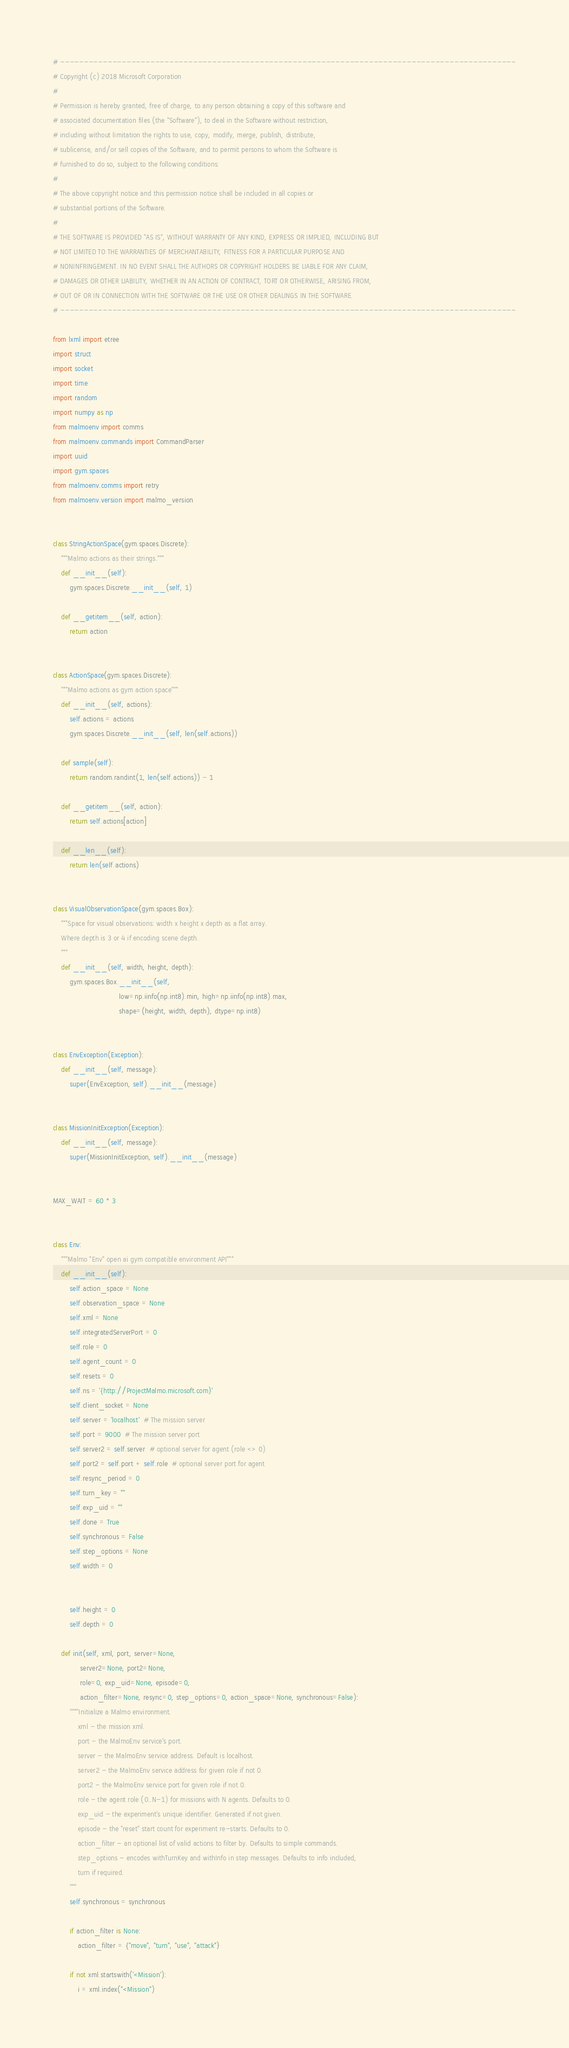Convert code to text. <code><loc_0><loc_0><loc_500><loc_500><_Python_># ------------------------------------------------------------------------------------------------
# Copyright (c) 2018 Microsoft Corporation
# 
# Permission is hereby granted, free of charge, to any person obtaining a copy of this software and
# associated documentation files (the "Software"), to deal in the Software without restriction,
# including without limitation the rights to use, copy, modify, merge, publish, distribute,
# sublicense, and/or sell copies of the Software, and to permit persons to whom the Software is
# furnished to do so, subject to the following conditions:
# 
# The above copyright notice and this permission notice shall be included in all copies or
# substantial portions of the Software.
# 
# THE SOFTWARE IS PROVIDED "AS IS", WITHOUT WARRANTY OF ANY KIND, EXPRESS OR IMPLIED, INCLUDING BUT
# NOT LIMITED TO THE WARRANTIES OF MERCHANTABILITY, FITNESS FOR A PARTICULAR PURPOSE AND
# NONINFRINGEMENT. IN NO EVENT SHALL THE AUTHORS OR COPYRIGHT HOLDERS BE LIABLE FOR ANY CLAIM,
# DAMAGES OR OTHER LIABILITY, WHETHER IN AN ACTION OF CONTRACT, TORT OR OTHERWISE, ARISING FROM,
# OUT OF OR IN CONNECTION WITH THE SOFTWARE OR THE USE OR OTHER DEALINGS IN THE SOFTWARE.
# ------------------------------------------------------------------------------------------------

from lxml import etree
import struct
import socket
import time
import random
import numpy as np
from malmoenv import comms
from malmoenv.commands import CommandParser
import uuid
import gym.spaces
from malmoenv.comms import retry
from malmoenv.version import malmo_version


class StringActionSpace(gym.spaces.Discrete):
    """Malmo actions as their strings."""
    def __init__(self):
        gym.spaces.Discrete.__init__(self, 1)

    def __getitem__(self, action):
        return action


class ActionSpace(gym.spaces.Discrete):
    """Malmo actions as gym action space"""
    def __init__(self, actions):
        self.actions = actions
        gym.spaces.Discrete.__init__(self, len(self.actions))

    def sample(self):
        return random.randint(1, len(self.actions)) - 1

    def __getitem__(self, action):
        return self.actions[action]

    def __len__(self):
        return len(self.actions)


class VisualObservationSpace(gym.spaces.Box):
    """Space for visual observations: width x height x depth as a flat array.
    Where depth is 3 or 4 if encoding scene depth.
    """
    def __init__(self, width, height, depth):
        gym.spaces.Box.__init__(self,
                                low=np.iinfo(np.int8).min, high=np.iinfo(np.int8).max,
                                shape=(height, width, depth), dtype=np.int8)


class EnvException(Exception):
    def __init__(self, message):
        super(EnvException, self).__init__(message)


class MissionInitException(Exception):
    def __init__(self, message):
        super(MissionInitException, self).__init__(message)


MAX_WAIT = 60 * 3


class Env:
    """Malmo "Env" open ai gym compatible environment API"""
    def __init__(self):
        self.action_space = None
        self.observation_space = None
        self.xml = None
        self.integratedServerPort = 0
        self.role = 0
        self.agent_count = 0
        self.resets = 0
        self.ns = '{http://ProjectMalmo.microsoft.com}'
        self.client_socket = None
        self.server = 'localhost'  # The mission server
        self.port = 9000  # The mission server port
        self.server2 = self.server  # optional server for agent (role <> 0)
        self.port2 = self.port + self.role  # optional server port for agent
        self.resync_period = 0
        self.turn_key = ""
        self.exp_uid = ""
        self.done = True
        self.synchronous = False
        self.step_options = None
        self.width = 0

        
        self.height = 0
        self.depth = 0

    def init(self, xml, port, server=None,
             server2=None, port2=None,
             role=0, exp_uid=None, episode=0,
             action_filter=None, resync=0, step_options=0, action_space=None, synchronous=False):
        """"Initialize a Malmo environment.
            xml - the mission xml.
            port - the MalmoEnv service's port.
            server - the MalmoEnv service address. Default is localhost.
            server2 - the MalmoEnv service address for given role if not 0.
            port2 - the MalmoEnv service port for given role if not 0.
            role - the agent role (0..N-1) for missions with N agents. Defaults to 0.
            exp_uid - the experiment's unique identifier. Generated if not given.
            episode - the "reset" start count for experiment re-starts. Defaults to 0.
            action_filter - an optional list of valid actions to filter by. Defaults to simple commands.
            step_options - encodes withTurnKey and withInfo in step messages. Defaults to info included,
            turn if required.
        """
        self.synchronous = synchronous

        if action_filter is None:
            action_filter = {"move", "turn", "use", "attack"}

        if not xml.startswith('<Mission'):
            i = xml.index("<Mission")</code> 